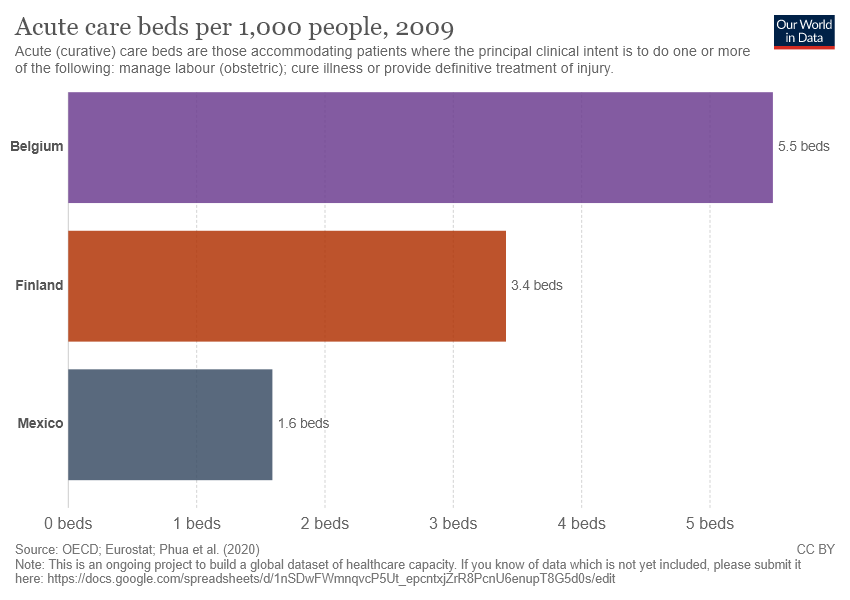Draw attention to some important aspects in this diagram. There are three categories in the chart. The average of the two smallest bars is 2.5. 